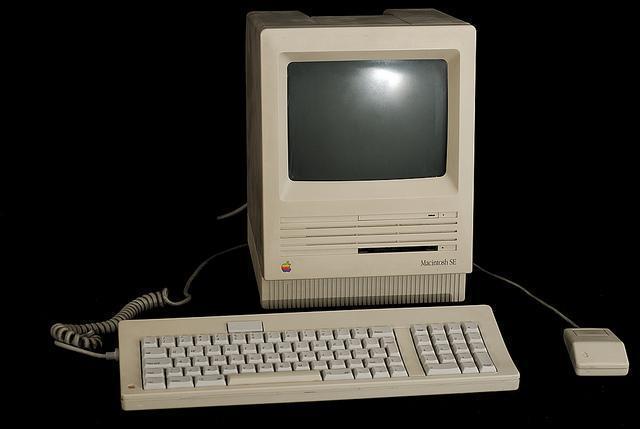How many keyboards are in the picture?
Give a very brief answer. 1. How many mice are there?
Give a very brief answer. 1. How many people are riding bikes?
Give a very brief answer. 0. 